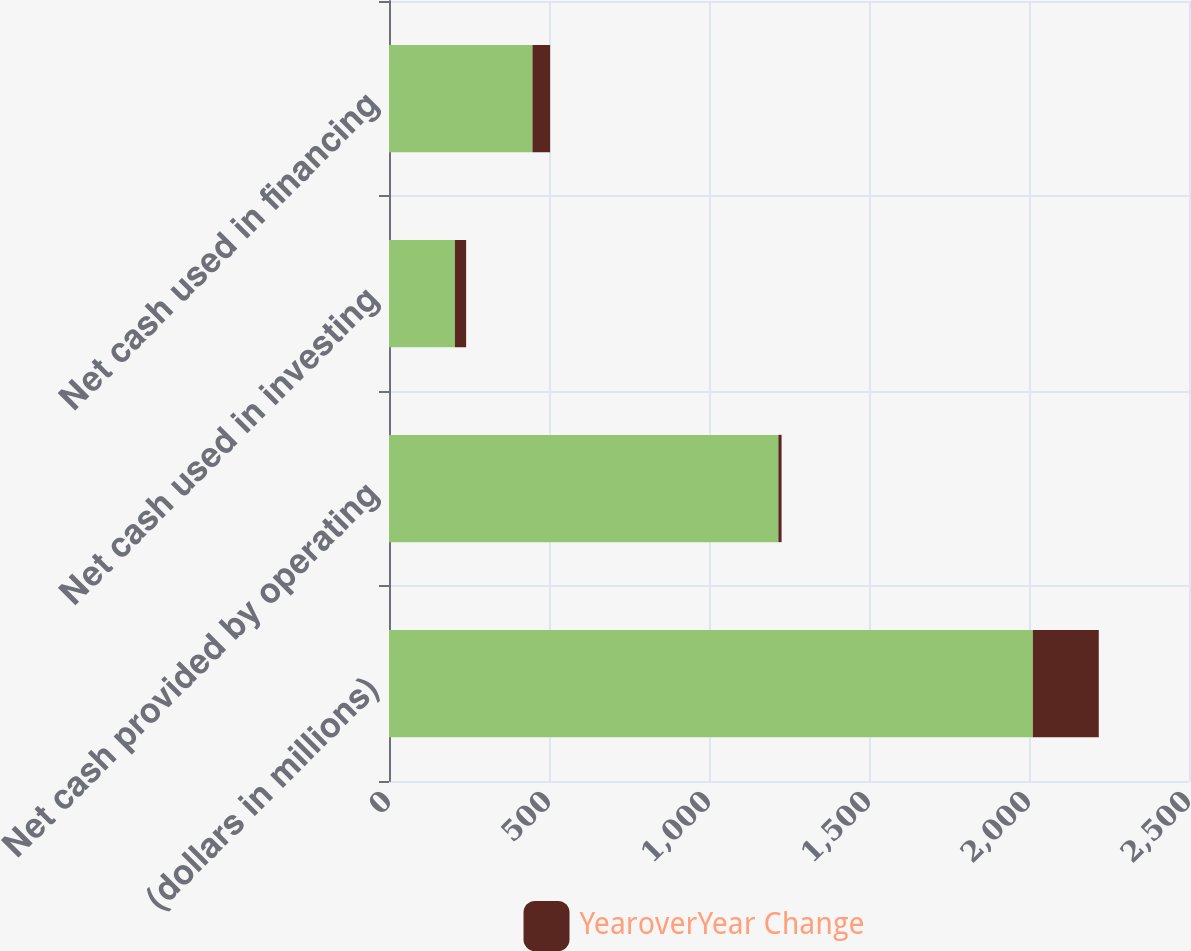Convert chart to OTSL. <chart><loc_0><loc_0><loc_500><loc_500><stacked_bar_chart><ecel><fcel>(dollars in millions)<fcel>Net cash provided by operating<fcel>Net cash used in investing<fcel>Net cash used in financing<nl><fcel>nan<fcel>2012<fcel>1216.8<fcel>206<fcel>448.4<nl><fcel>YearoverYear Change<fcel>206<fcel>10<fcel>35<fcel>55<nl></chart> 